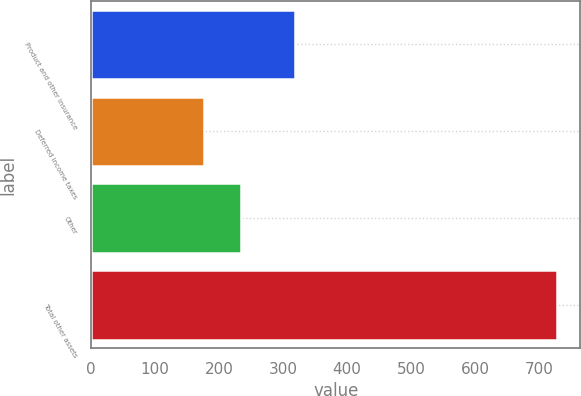<chart> <loc_0><loc_0><loc_500><loc_500><bar_chart><fcel>Product and other insurance<fcel>Deferred income taxes<fcel>Other<fcel>Total other assets<nl><fcel>318<fcel>176<fcel>234<fcel>728<nl></chart> 